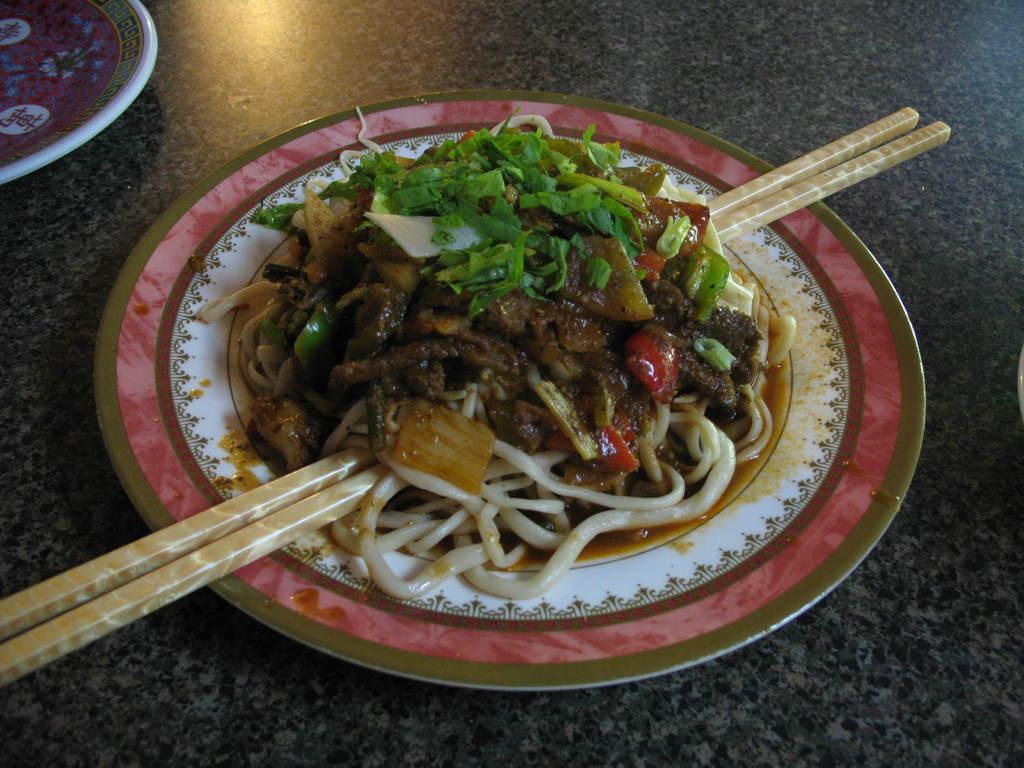How would you summarize this image in a sentence or two? there is a plate on which there is a food and chopsticks. 